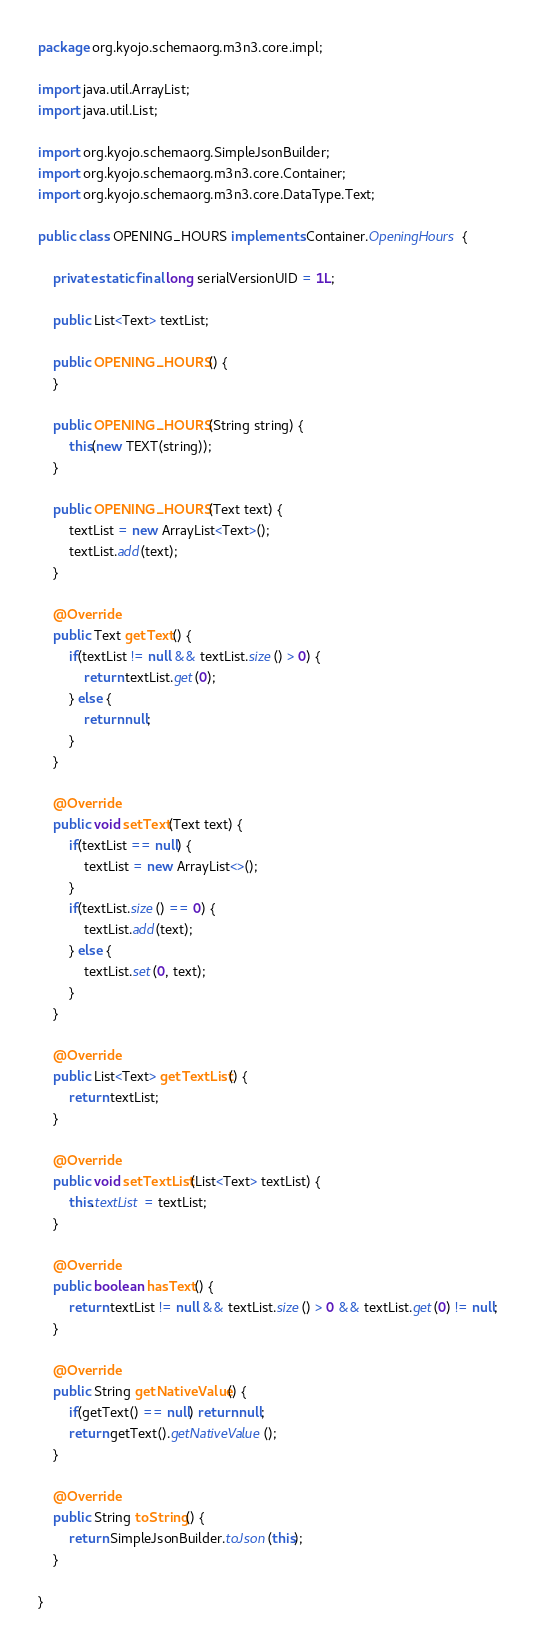<code> <loc_0><loc_0><loc_500><loc_500><_Java_>package org.kyojo.schemaorg.m3n3.core.impl;

import java.util.ArrayList;
import java.util.List;

import org.kyojo.schemaorg.SimpleJsonBuilder;
import org.kyojo.schemaorg.m3n3.core.Container;
import org.kyojo.schemaorg.m3n3.core.DataType.Text;

public class OPENING_HOURS implements Container.OpeningHours {

	private static final long serialVersionUID = 1L;

	public List<Text> textList;

	public OPENING_HOURS() {
	}

	public OPENING_HOURS(String string) {
		this(new TEXT(string));
	}

	public OPENING_HOURS(Text text) {
		textList = new ArrayList<Text>();
		textList.add(text);
	}

	@Override
	public Text getText() {
		if(textList != null && textList.size() > 0) {
			return textList.get(0);
		} else {
			return null;
		}
	}

	@Override
	public void setText(Text text) {
		if(textList == null) {
			textList = new ArrayList<>();
		}
		if(textList.size() == 0) {
			textList.add(text);
		} else {
			textList.set(0, text);
		}
	}

	@Override
	public List<Text> getTextList() {
		return textList;
	}

	@Override
	public void setTextList(List<Text> textList) {
		this.textList = textList;
	}

	@Override
	public boolean hasText() {
		return textList != null && textList.size() > 0 && textList.get(0) != null;
	}

	@Override
	public String getNativeValue() {
		if(getText() == null) return null;
		return getText().getNativeValue();
	}

	@Override
	public String toString() {
		return SimpleJsonBuilder.toJson(this);
	}

}
</code> 